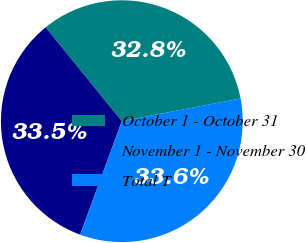<chart> <loc_0><loc_0><loc_500><loc_500><pie_chart><fcel>October 1 - October 31<fcel>November 1 - November 30<fcel>Total T<nl><fcel>32.84%<fcel>33.54%<fcel>33.61%<nl></chart> 